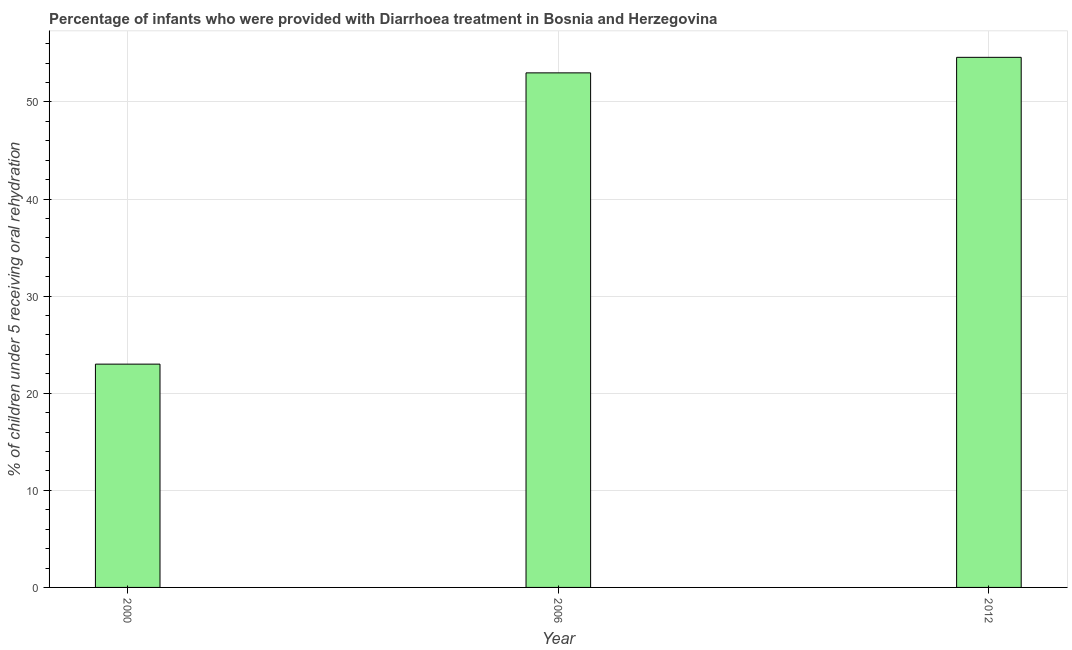What is the title of the graph?
Ensure brevity in your answer.  Percentage of infants who were provided with Diarrhoea treatment in Bosnia and Herzegovina. What is the label or title of the Y-axis?
Offer a terse response. % of children under 5 receiving oral rehydration. What is the percentage of children who were provided with treatment diarrhoea in 2012?
Provide a short and direct response. 54.6. Across all years, what is the maximum percentage of children who were provided with treatment diarrhoea?
Provide a succinct answer. 54.6. Across all years, what is the minimum percentage of children who were provided with treatment diarrhoea?
Offer a very short reply. 23. In which year was the percentage of children who were provided with treatment diarrhoea maximum?
Offer a terse response. 2012. In which year was the percentage of children who were provided with treatment diarrhoea minimum?
Make the answer very short. 2000. What is the sum of the percentage of children who were provided with treatment diarrhoea?
Offer a very short reply. 130.6. What is the average percentage of children who were provided with treatment diarrhoea per year?
Offer a terse response. 43.53. What is the median percentage of children who were provided with treatment diarrhoea?
Provide a short and direct response. 53. Is the percentage of children who were provided with treatment diarrhoea in 2000 less than that in 2006?
Offer a terse response. Yes. What is the difference between the highest and the second highest percentage of children who were provided with treatment diarrhoea?
Make the answer very short. 1.6. What is the difference between the highest and the lowest percentage of children who were provided with treatment diarrhoea?
Provide a succinct answer. 31.6. In how many years, is the percentage of children who were provided with treatment diarrhoea greater than the average percentage of children who were provided with treatment diarrhoea taken over all years?
Offer a terse response. 2. Are all the bars in the graph horizontal?
Your answer should be very brief. No. How many years are there in the graph?
Your answer should be compact. 3. What is the difference between two consecutive major ticks on the Y-axis?
Give a very brief answer. 10. What is the % of children under 5 receiving oral rehydration in 2006?
Keep it short and to the point. 53. What is the % of children under 5 receiving oral rehydration in 2012?
Offer a very short reply. 54.6. What is the difference between the % of children under 5 receiving oral rehydration in 2000 and 2006?
Ensure brevity in your answer.  -30. What is the difference between the % of children under 5 receiving oral rehydration in 2000 and 2012?
Offer a very short reply. -31.6. What is the difference between the % of children under 5 receiving oral rehydration in 2006 and 2012?
Give a very brief answer. -1.6. What is the ratio of the % of children under 5 receiving oral rehydration in 2000 to that in 2006?
Offer a very short reply. 0.43. What is the ratio of the % of children under 5 receiving oral rehydration in 2000 to that in 2012?
Offer a terse response. 0.42. What is the ratio of the % of children under 5 receiving oral rehydration in 2006 to that in 2012?
Provide a succinct answer. 0.97. 